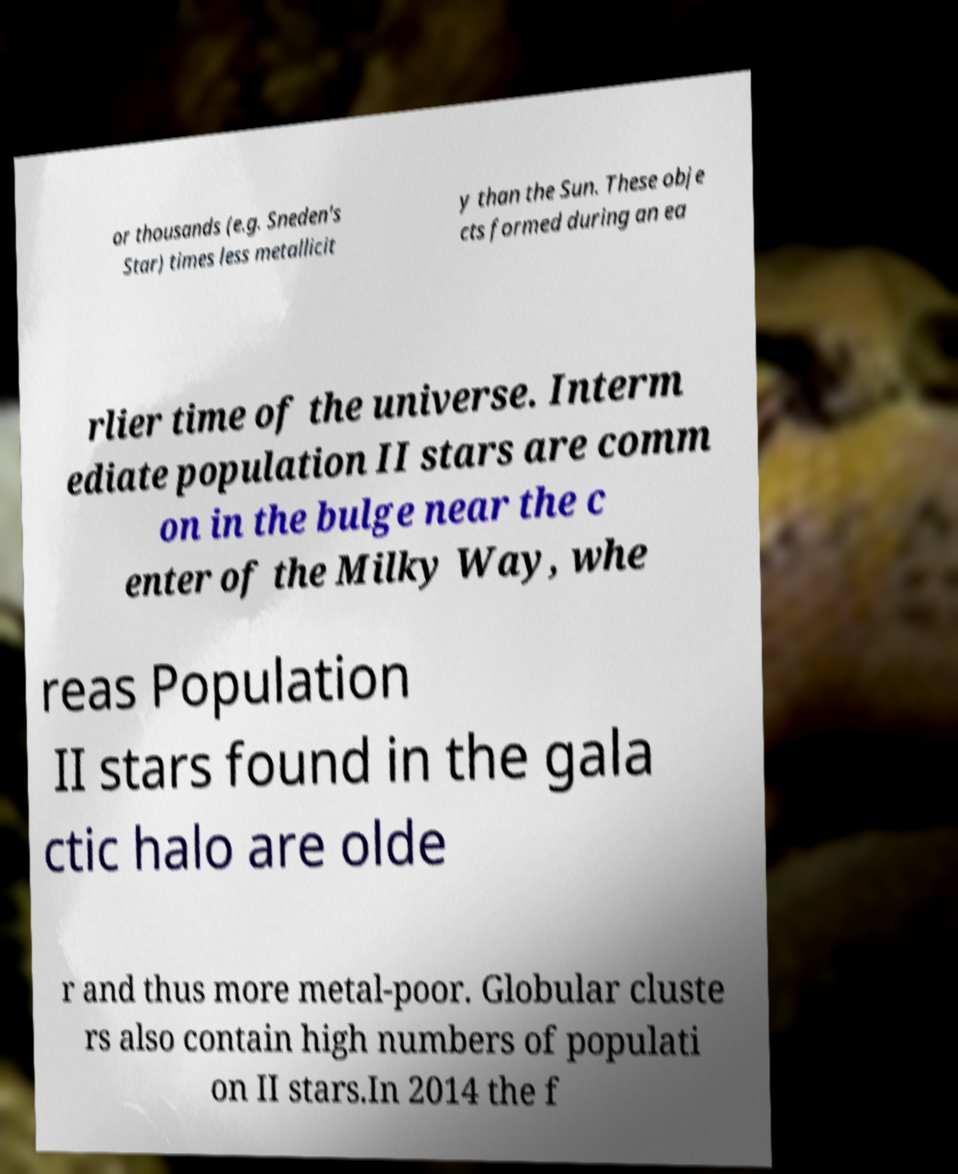Can you read and provide the text displayed in the image?This photo seems to have some interesting text. Can you extract and type it out for me? or thousands (e.g. Sneden's Star) times less metallicit y than the Sun. These obje cts formed during an ea rlier time of the universe. Interm ediate population II stars are comm on in the bulge near the c enter of the Milky Way, whe reas Population II stars found in the gala ctic halo are olde r and thus more metal-poor. Globular cluste rs also contain high numbers of populati on II stars.In 2014 the f 